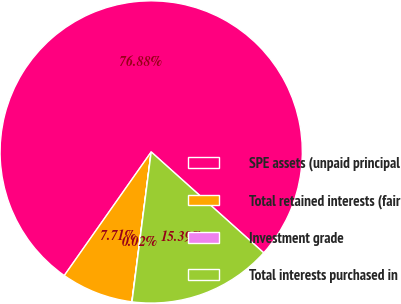Convert chart to OTSL. <chart><loc_0><loc_0><loc_500><loc_500><pie_chart><fcel>SPE assets (unpaid principal<fcel>Total retained interests (fair<fcel>Investment grade<fcel>Total interests purchased in<nl><fcel>76.88%<fcel>7.71%<fcel>0.02%<fcel>15.39%<nl></chart> 